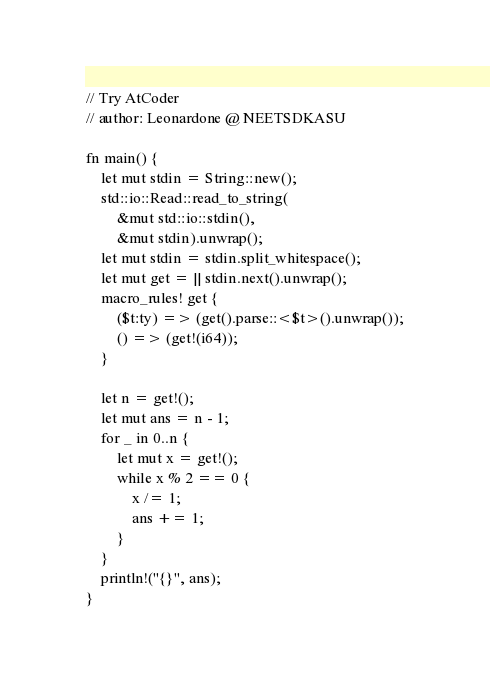<code> <loc_0><loc_0><loc_500><loc_500><_Rust_>// Try AtCoder
// author: Leonardone @ NEETSDKASU

fn main() {
	let mut stdin = String::new();
    std::io::Read::read_to_string(
    	&mut std::io::stdin(),
        &mut stdin).unwrap();
    let mut stdin = stdin.split_whitespace();
    let mut get = || stdin.next().unwrap();
    macro_rules! get {
    	($t:ty) => (get().parse::<$t>().unwrap());
        () => (get!(i64));
    }
    
    let n = get!();
    let mut ans = n - 1;
    for _ in 0..n {
    	let mut x = get!();
        while x % 2 == 0 {
        	x /= 1;
            ans += 1;
        }
    }
    println!("{}", ans);
}</code> 